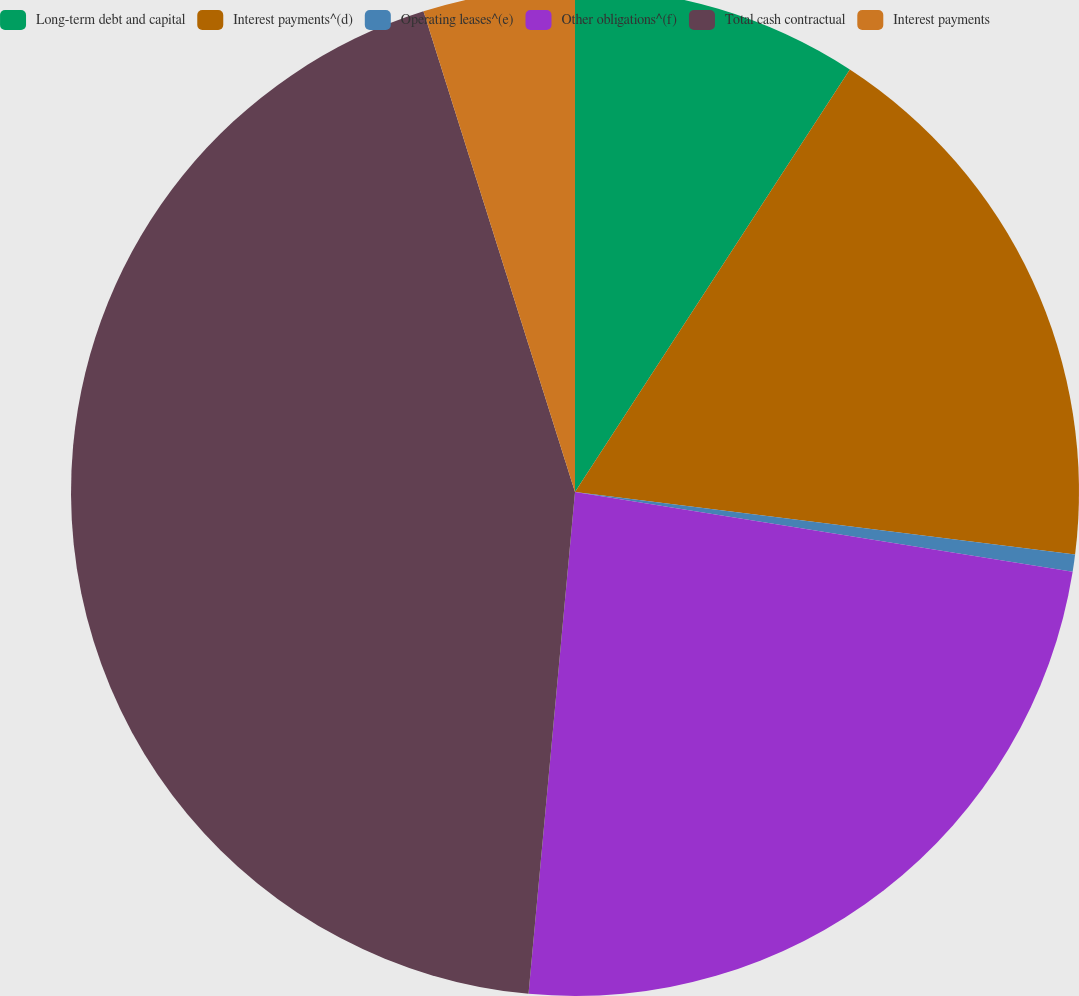Convert chart. <chart><loc_0><loc_0><loc_500><loc_500><pie_chart><fcel>Long-term debt and capital<fcel>Interest payments^(d)<fcel>Operating leases^(e)<fcel>Other obligations^(f)<fcel>Total cash contractual<fcel>Interest payments<nl><fcel>9.18%<fcel>17.8%<fcel>0.55%<fcel>23.94%<fcel>43.67%<fcel>4.86%<nl></chart> 